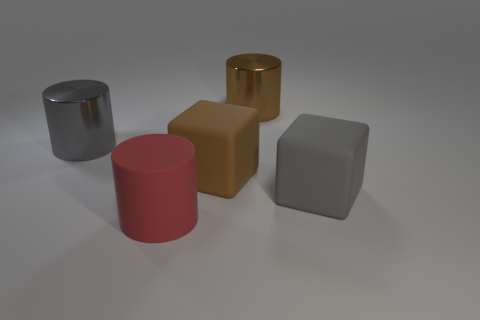Can you guess the setting or the type of place in which this photo might have been taken? The setting in the image is quite minimalistic with a neutral and plain background that suggests a controlled environment, possibly a studio setup for product photography. The lighting and the shadows imply that care has been taken in presenting these objects, which is typical of a professional shoot designed to highlight the form and material of the objects without any distractions. 